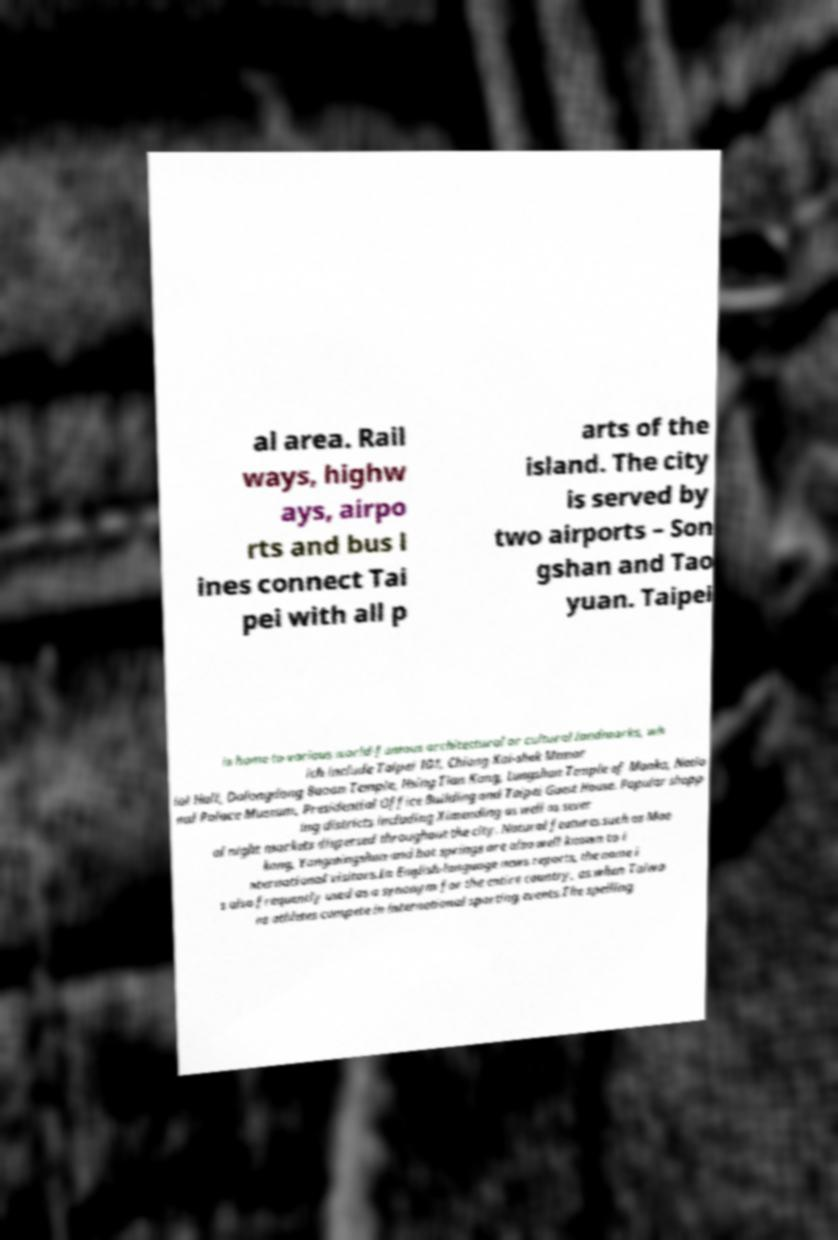Could you assist in decoding the text presented in this image and type it out clearly? al area. Rail ways, highw ays, airpo rts and bus l ines connect Tai pei with all p arts of the island. The city is served by two airports – Son gshan and Tao yuan. Taipei is home to various world-famous architectural or cultural landmarks, wh ich include Taipei 101, Chiang Kai-shek Memor ial Hall, Dalongdong Baoan Temple, Hsing Tian Kong, Lungshan Temple of Manka, Natio nal Palace Museum, Presidential Office Building and Taipei Guest House. Popular shopp ing districts including Ximending as well as sever al night markets dispersed throughout the city. Natural features such as Mao kong, Yangmingshan and hot springs are also well known to i nternational visitors.In English-language news reports, the name i s also frequently used as a synonym for the entire country, as when Taiwa ns athletes compete in international sporting events.The spelling 